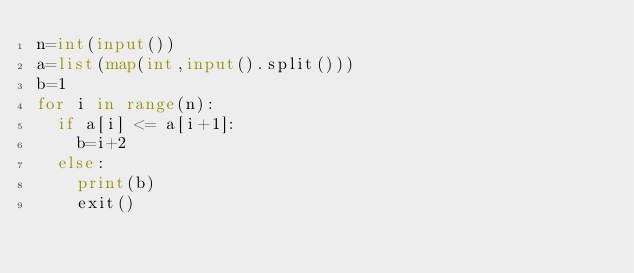<code> <loc_0><loc_0><loc_500><loc_500><_Python_>n=int(input())
a=list(map(int,input().split()))
b=1
for i in range(n):
  if a[i] <= a[i+1]:
    b=i+2
  else:
    print(b)
    exit()</code> 